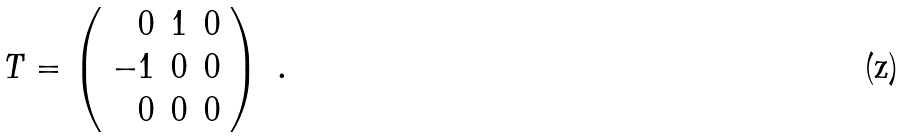<formula> <loc_0><loc_0><loc_500><loc_500>T = \left ( \begin{array} { r r r } 0 & 1 & 0 \\ - 1 & 0 & 0 \\ 0 & 0 & 0 \end{array} \right ) \ .</formula> 